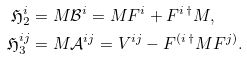<formula> <loc_0><loc_0><loc_500><loc_500>\mathfrak H _ { 2 } ^ { i } & = M \mathcal { B } ^ { i } = M F ^ { i } + F ^ { i \, \dag } M , \\ \mathfrak H _ { 3 } ^ { i j } & = M \mathcal { A } ^ { i j } = V ^ { i j } - F ^ { ( i \, \dag } M F ^ { j ) } .</formula> 